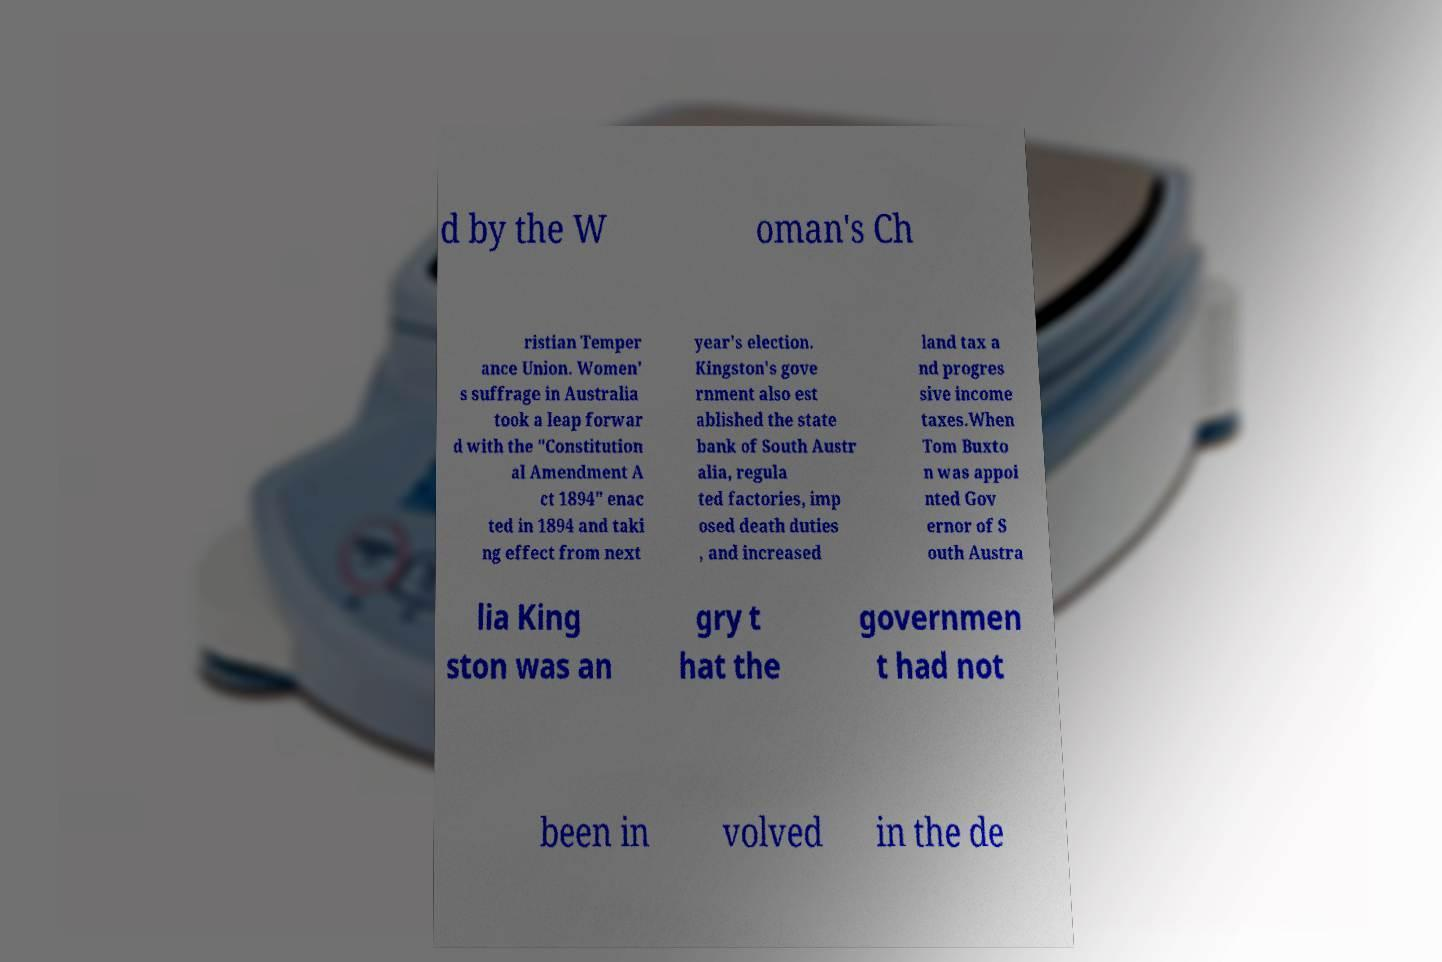There's text embedded in this image that I need extracted. Can you transcribe it verbatim? d by the W oman's Ch ristian Temper ance Union. Women' s suffrage in Australia took a leap forwar d with the "Constitution al Amendment A ct 1894" enac ted in 1894 and taki ng effect from next year's election. Kingston's gove rnment also est ablished the state bank of South Austr alia, regula ted factories, imp osed death duties , and increased land tax a nd progres sive income taxes.When Tom Buxto n was appoi nted Gov ernor of S outh Austra lia King ston was an gry t hat the governmen t had not been in volved in the de 